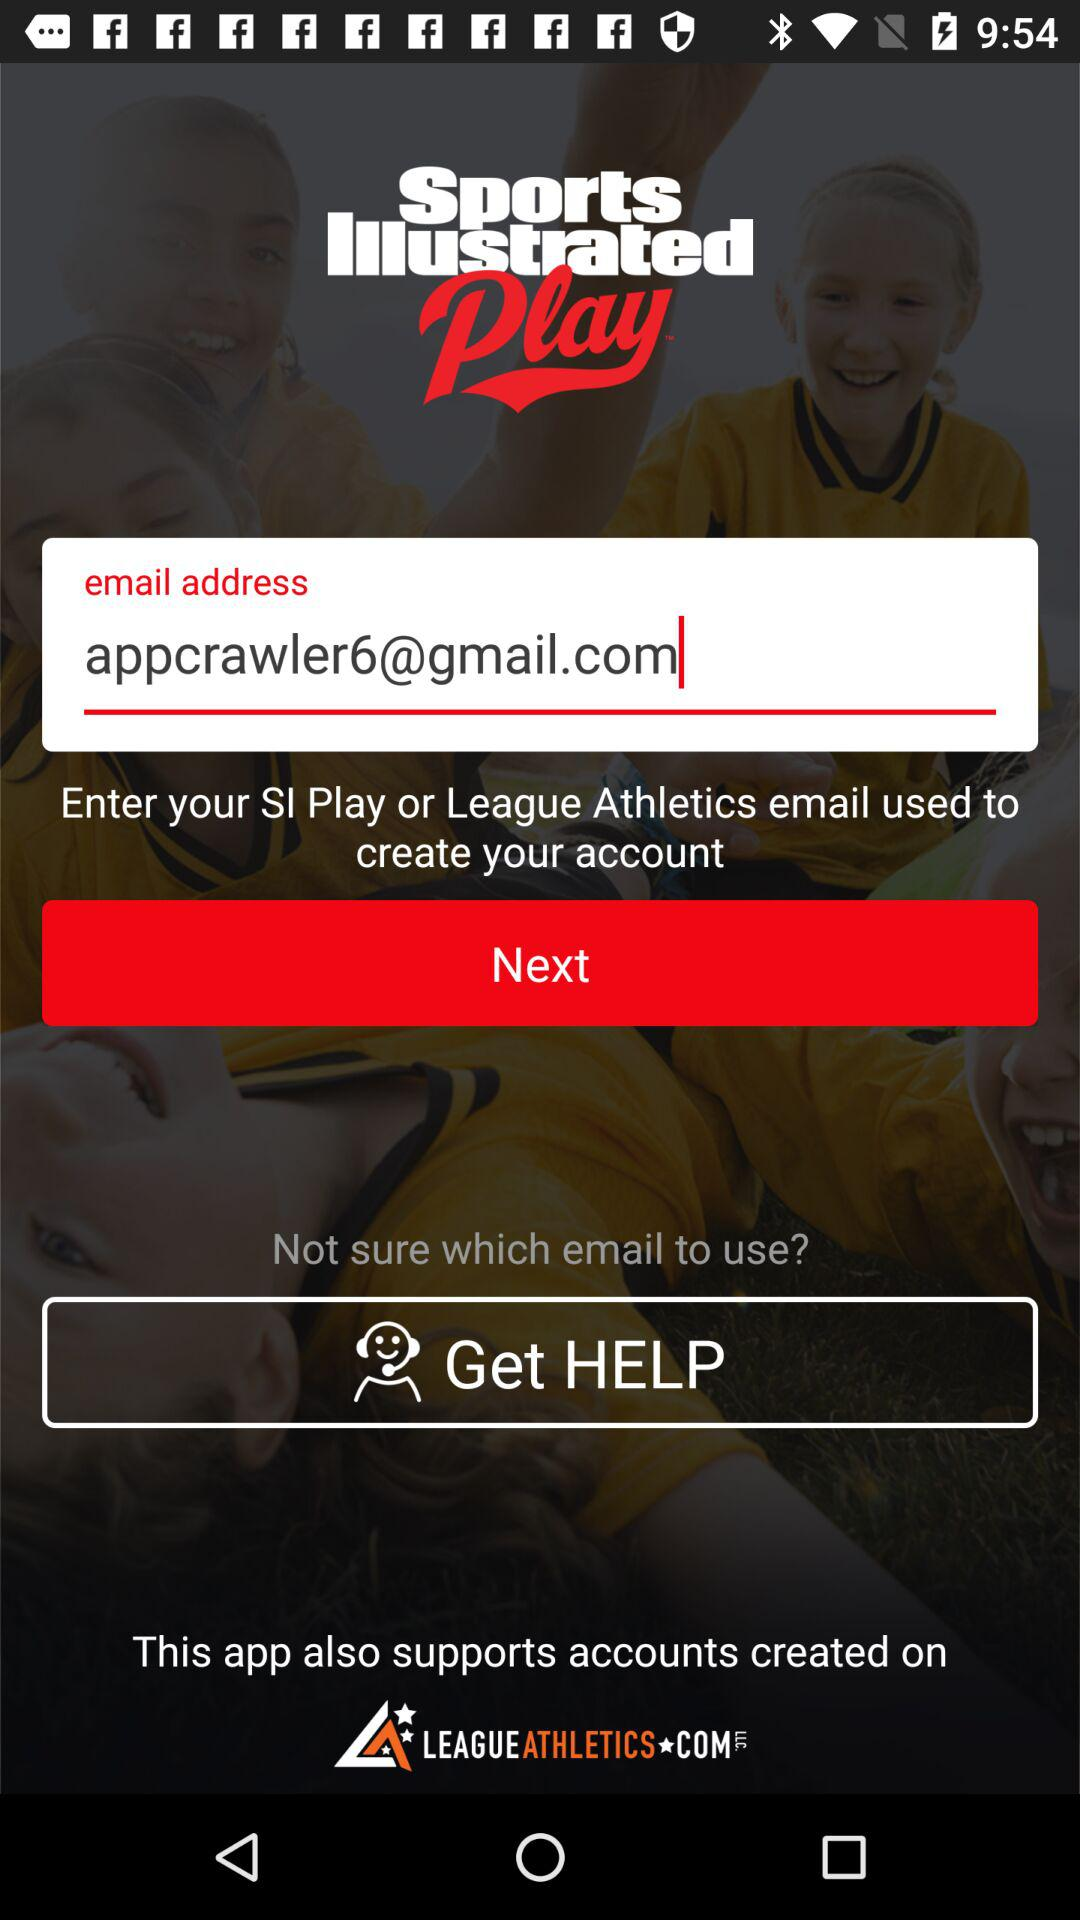What’s the app name? The app name is "Sports Illustrated Play". 